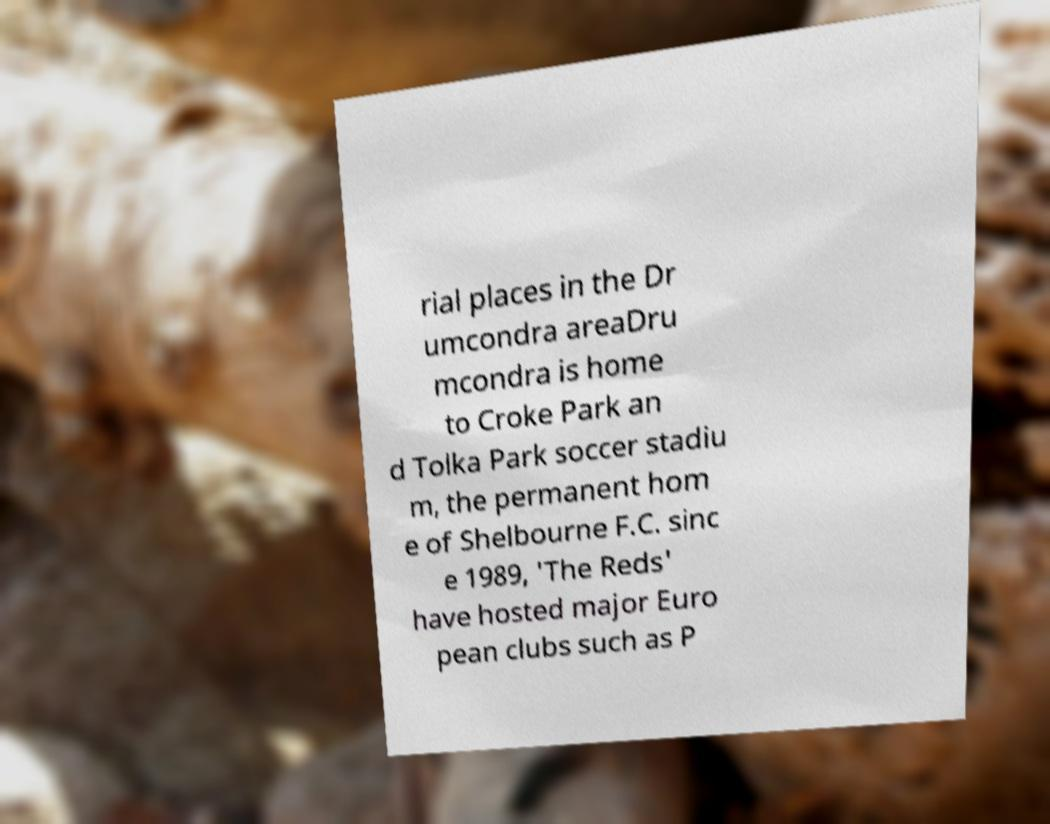Can you read and provide the text displayed in the image?This photo seems to have some interesting text. Can you extract and type it out for me? rial places in the Dr umcondra areaDru mcondra is home to Croke Park an d Tolka Park soccer stadiu m, the permanent hom e of Shelbourne F.C. sinc e 1989, 'The Reds' have hosted major Euro pean clubs such as P 